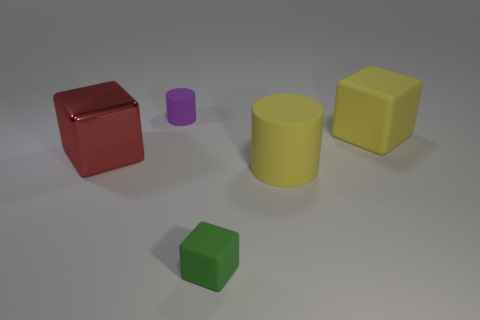There is a small thing in front of the purple thing; is there a yellow cylinder that is in front of it?
Your response must be concise. No. There is a tiny green object that is the same material as the yellow block; what is its shape?
Give a very brief answer. Cube. Is there any other thing of the same color as the metallic block?
Make the answer very short. No. There is a large red thing that is the same shape as the small green rubber thing; what material is it?
Give a very brief answer. Metal. What number of other things are there of the same size as the green cube?
Your response must be concise. 1. There is a large object left of the green thing; is it the same shape as the small green thing?
Your answer should be compact. Yes. What number of other objects are there of the same shape as the big red shiny object?
Give a very brief answer. 2. What is the shape of the large object that is behind the large shiny cube?
Keep it short and to the point. Cube. Is there a yellow object that has the same material as the purple object?
Your answer should be very brief. Yes. There is a big cube to the right of the yellow matte cylinder; is its color the same as the big cylinder?
Ensure brevity in your answer.  Yes. 